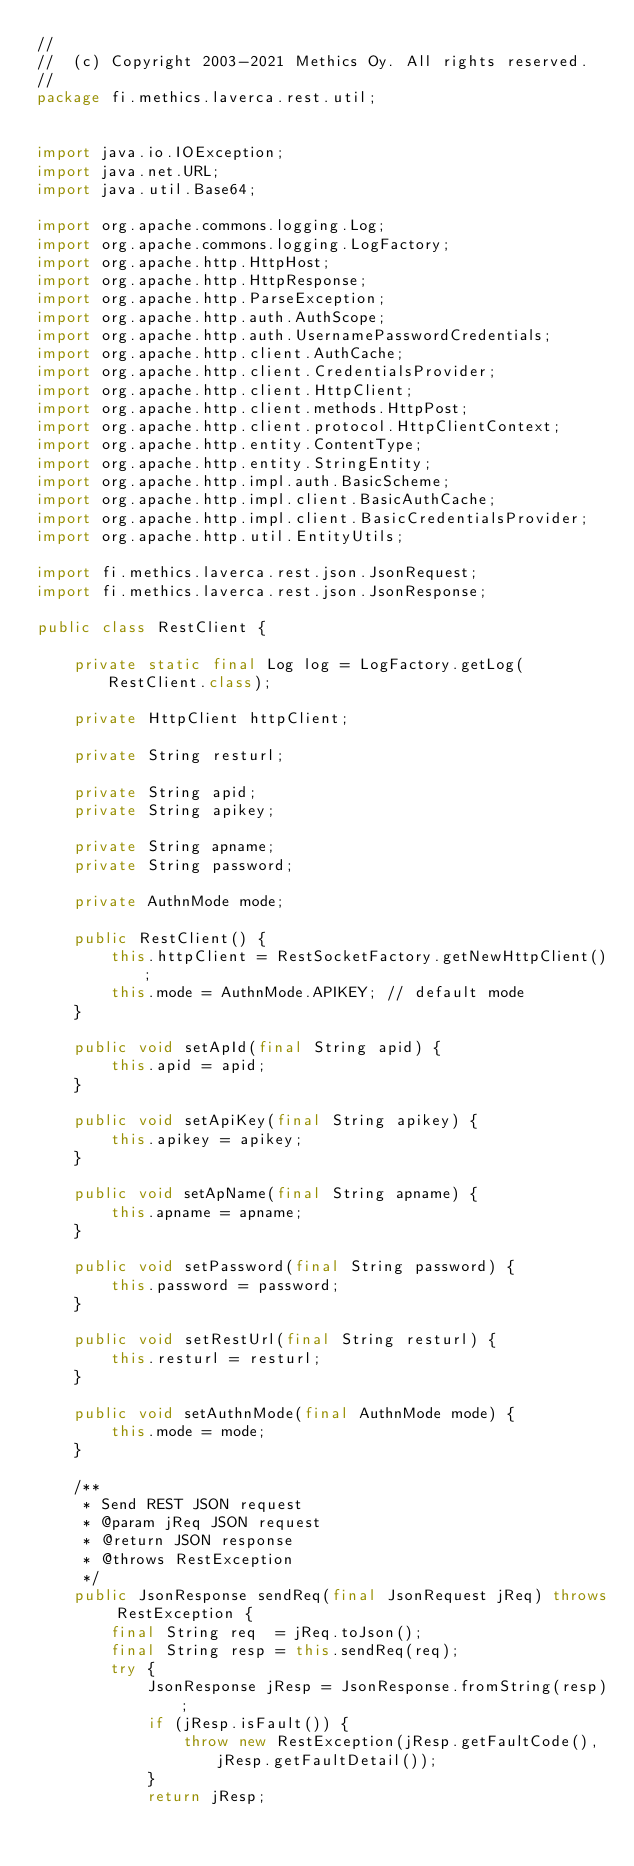<code> <loc_0><loc_0><loc_500><loc_500><_Java_>//
//  (c) Copyright 2003-2021 Methics Oy. All rights reserved. 
//
package fi.methics.laverca.rest.util;


import java.io.IOException;
import java.net.URL;
import java.util.Base64;

import org.apache.commons.logging.Log;
import org.apache.commons.logging.LogFactory;
import org.apache.http.HttpHost;
import org.apache.http.HttpResponse;
import org.apache.http.ParseException;
import org.apache.http.auth.AuthScope;
import org.apache.http.auth.UsernamePasswordCredentials;
import org.apache.http.client.AuthCache;
import org.apache.http.client.CredentialsProvider;
import org.apache.http.client.HttpClient;
import org.apache.http.client.methods.HttpPost;
import org.apache.http.client.protocol.HttpClientContext;
import org.apache.http.entity.ContentType;
import org.apache.http.entity.StringEntity;
import org.apache.http.impl.auth.BasicScheme;
import org.apache.http.impl.client.BasicAuthCache;
import org.apache.http.impl.client.BasicCredentialsProvider;
import org.apache.http.util.EntityUtils;

import fi.methics.laverca.rest.json.JsonRequest;
import fi.methics.laverca.rest.json.JsonResponse;

public class RestClient {

    private static final Log log = LogFactory.getLog(RestClient.class);
    
    private HttpClient httpClient;

    private String resturl;
    
    private String apid;
    private String apikey;
    
    private String apname;
    private String password;
    
    private AuthnMode mode;
    
    public RestClient() {
        this.httpClient = RestSocketFactory.getNewHttpClient();
        this.mode = AuthnMode.APIKEY; // default mode
    }
    
    public void setApId(final String apid) {
        this.apid = apid;
    }
    
    public void setApiKey(final String apikey) {
        this.apikey = apikey;
    }
    
    public void setApName(final String apname) {
        this.apname = apname;
    }
    
    public void setPassword(final String password) {
        this.password = password;
    }
    
    public void setRestUrl(final String resturl) {
        this.resturl = resturl;
    }
    
    public void setAuthnMode(final AuthnMode mode) {
        this.mode = mode;
    }
    
    /**
     * Send REST JSON request
     * @param jReq JSON request
     * @return JSON response
     * @throws RestException 
     */
    public JsonResponse sendReq(final JsonRequest jReq) throws RestException {
        final String req  = jReq.toJson();
        final String resp = this.sendReq(req);
        try {
            JsonResponse jResp = JsonResponse.fromString(resp);
            if (jResp.isFault()) {
                throw new RestException(jResp.getFaultCode(), jResp.getFaultDetail());
            }
            return jResp;</code> 